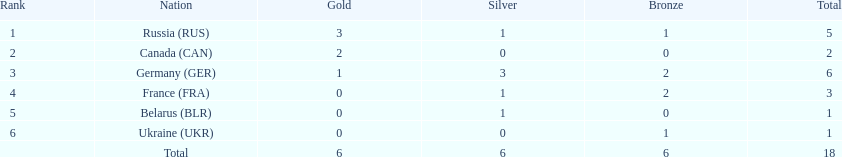What country only received gold medals in the 1994 winter olympics biathlon? Canada (CAN). 